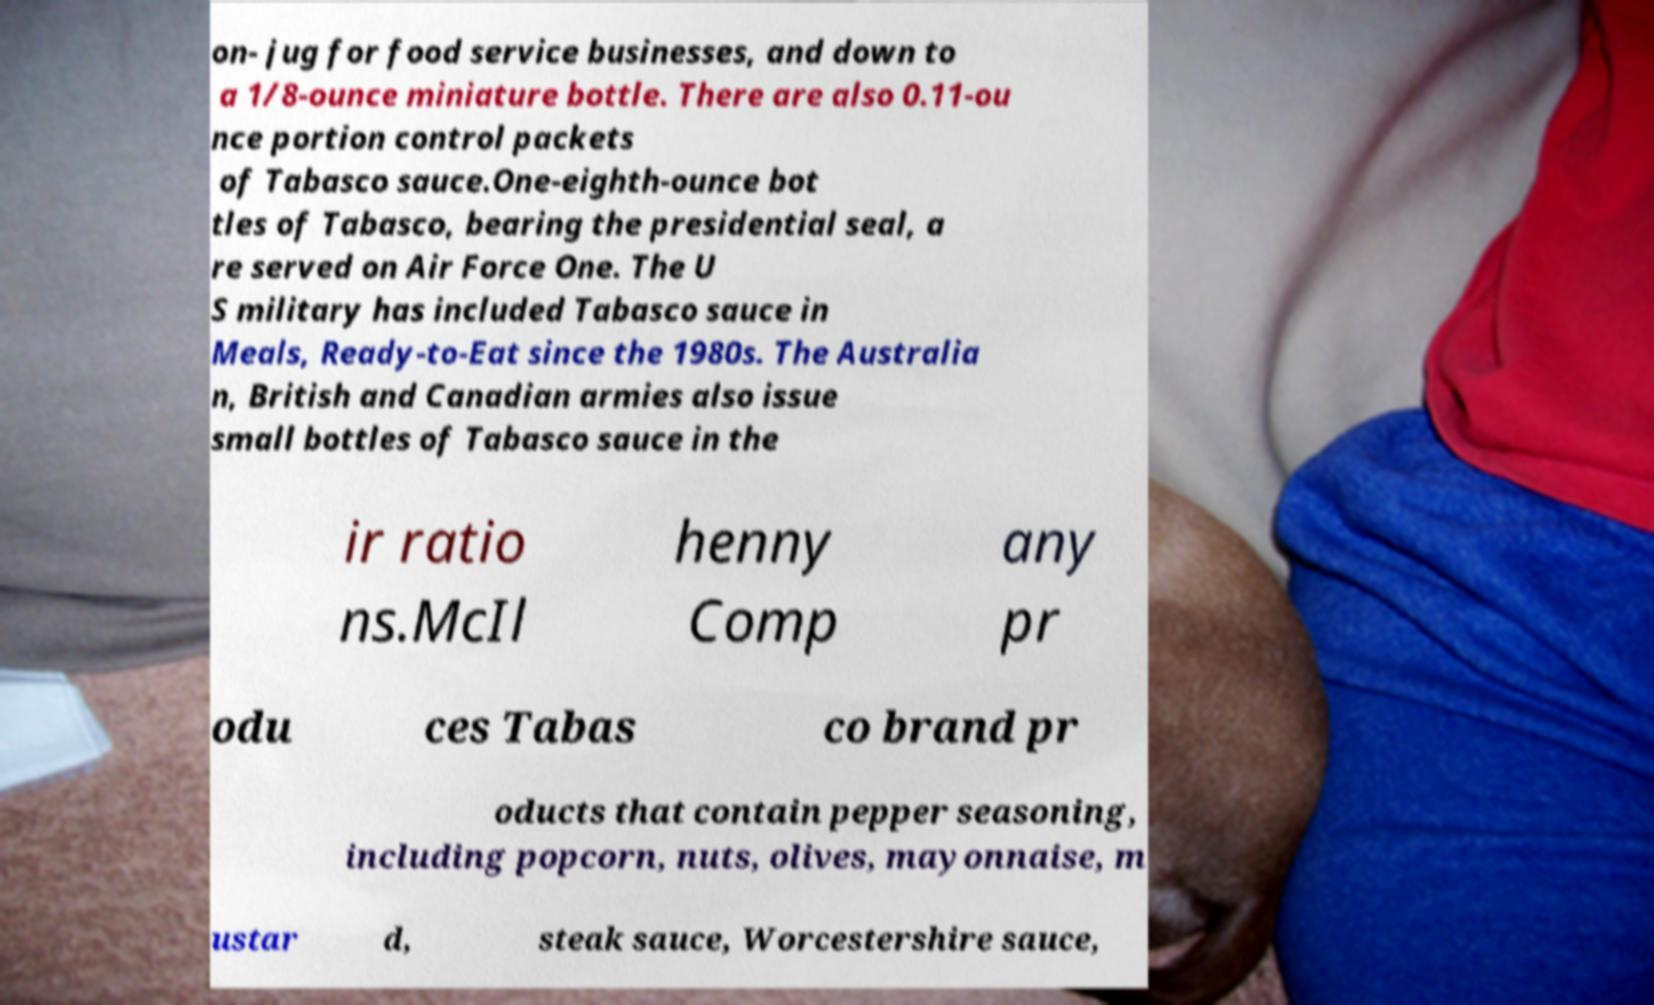Please read and relay the text visible in this image. What does it say? on- jug for food service businesses, and down to a 1/8-ounce miniature bottle. There are also 0.11-ou nce portion control packets of Tabasco sauce.One-eighth-ounce bot tles of Tabasco, bearing the presidential seal, a re served on Air Force One. The U S military has included Tabasco sauce in Meals, Ready-to-Eat since the 1980s. The Australia n, British and Canadian armies also issue small bottles of Tabasco sauce in the ir ratio ns.McIl henny Comp any pr odu ces Tabas co brand pr oducts that contain pepper seasoning, including popcorn, nuts, olives, mayonnaise, m ustar d, steak sauce, Worcestershire sauce, 